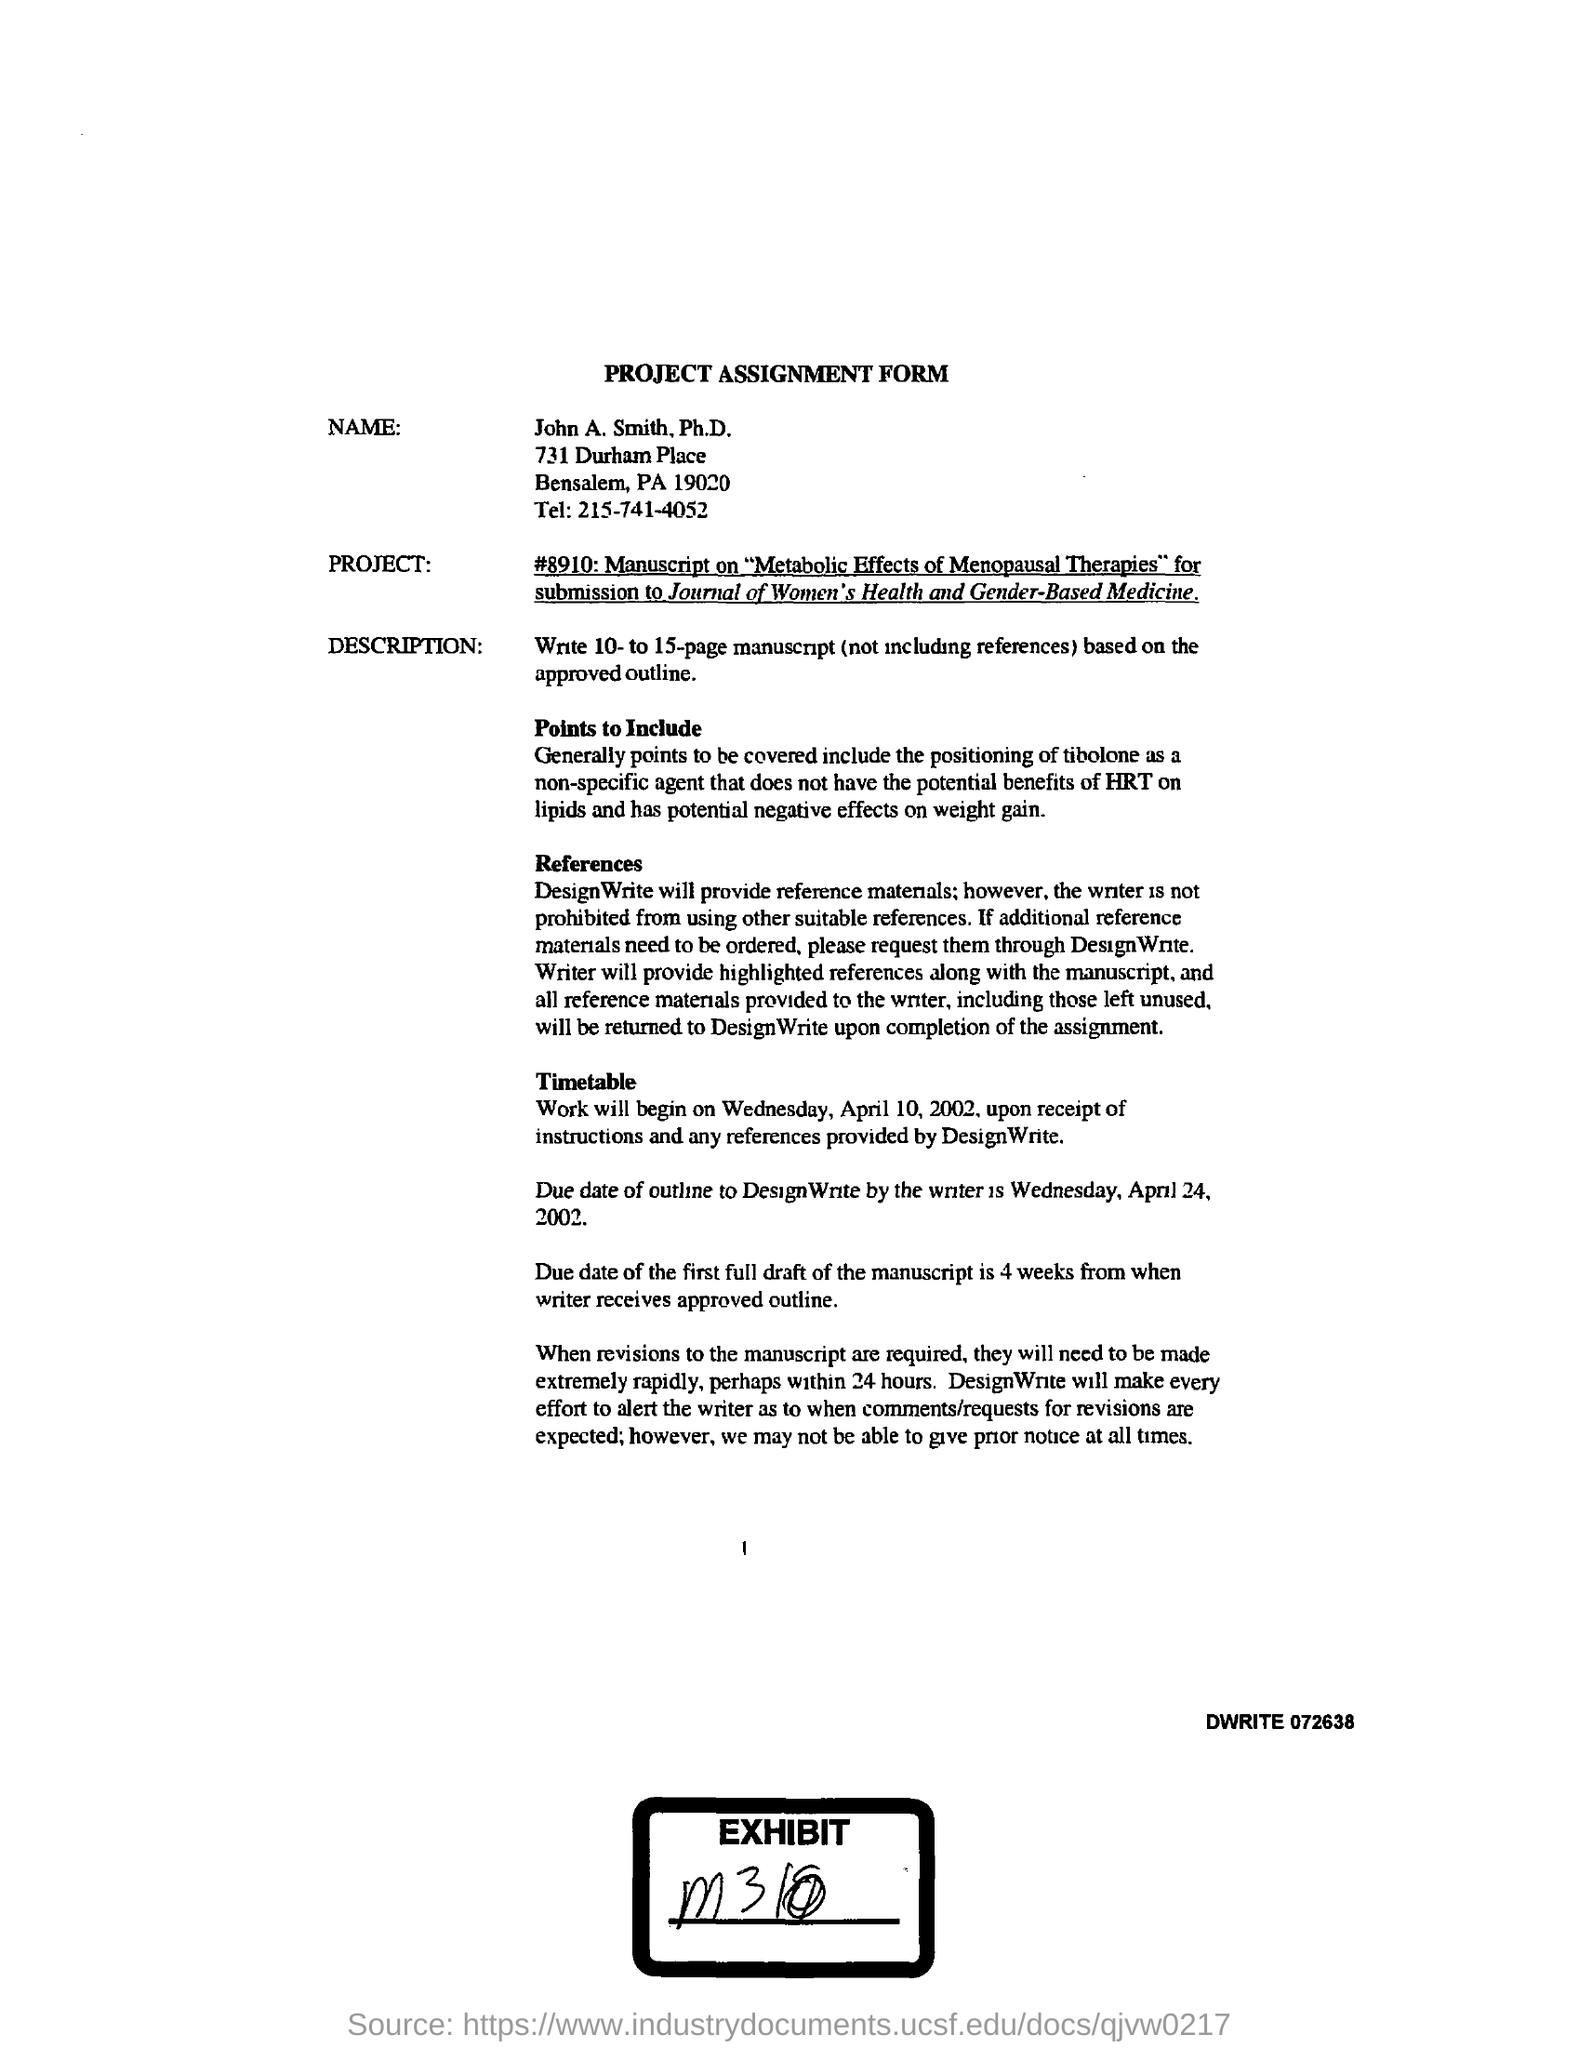Identify some key points in this picture. John A. Smith, Ph.D., provided the telephone number 215-741-4052. This is a project assignment form. 